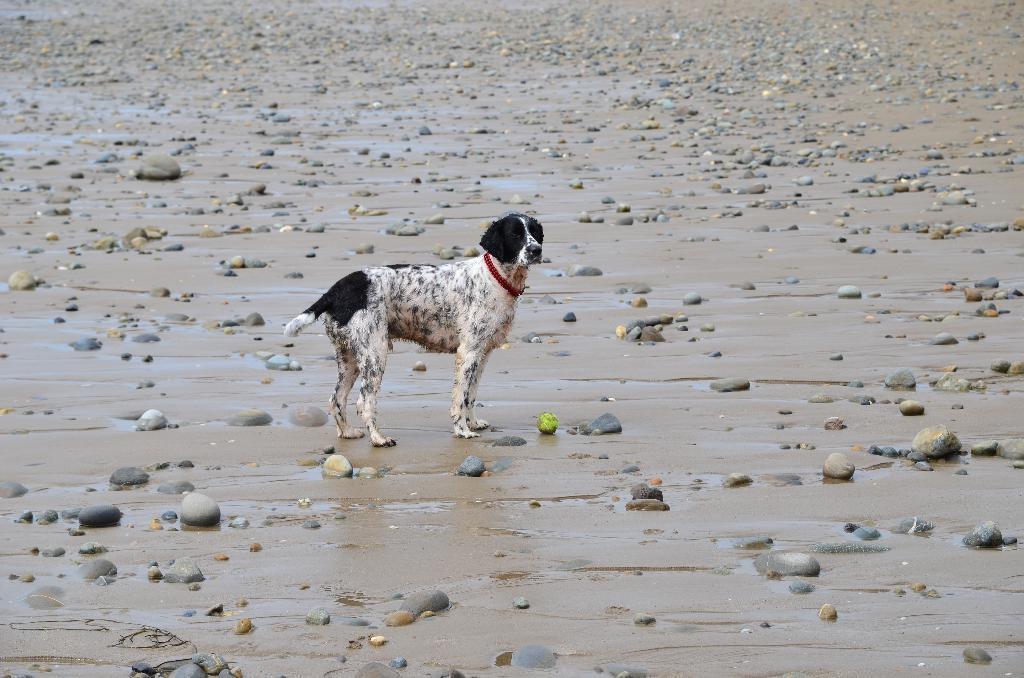How would you summarize this image in a sentence or two? In this picture we can see the wet sand. We can see the pebbles. We can see a dog and there is a belt around its neck. 